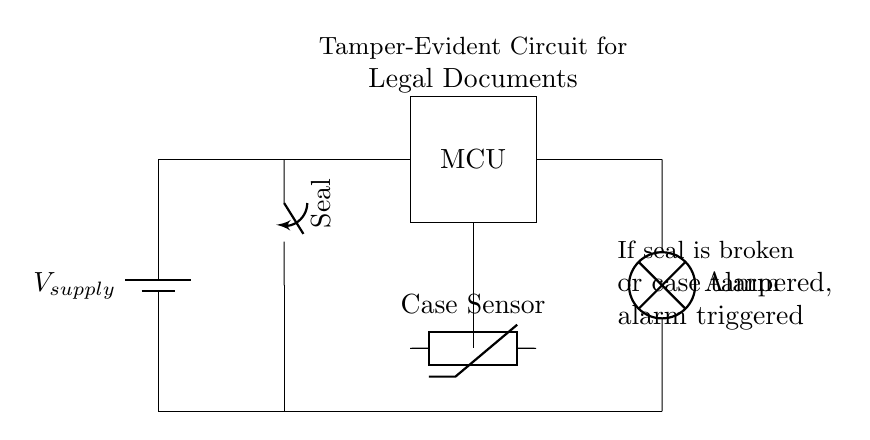What type of component is the main power supply? The main power supply is represented using a battery symbol, indicating that it provides electrical energy to the circuit.
Answer: Battery What does the seal component do? The seal component is a switch that indicates whether the tamper-evident feature is intact or broken. In this circuit, if the seal is broken, it leads to an alarm activation.
Answer: Switch How many components are there in this circuit? The circuit includes six components: a battery, a switch, a microcontroller, a lamp (alarm), a thermistor (case sensor), and three connections.
Answer: Six What happens if the document case is tampered with? If the document case is tampered with, the case sensor (thermistor) will detect the change, and this will lead to the alarm being triggered via the microcontroller.
Answer: Alarm triggered Which component is responsible for signaling detection of tampering? The thermistor, serving as the case sensor, is the component designed to detect tampering of the document case. Once activated, it sends a signal to the microcontroller.
Answer: Thermistor What is the relationship between the seal and the alarm in this circuit? The switch acts as a seal that, when opened (indicating tampering), will complete the circuit that leads to activating the alarm, demonstrating a direct association between the two.
Answer: Direct association 